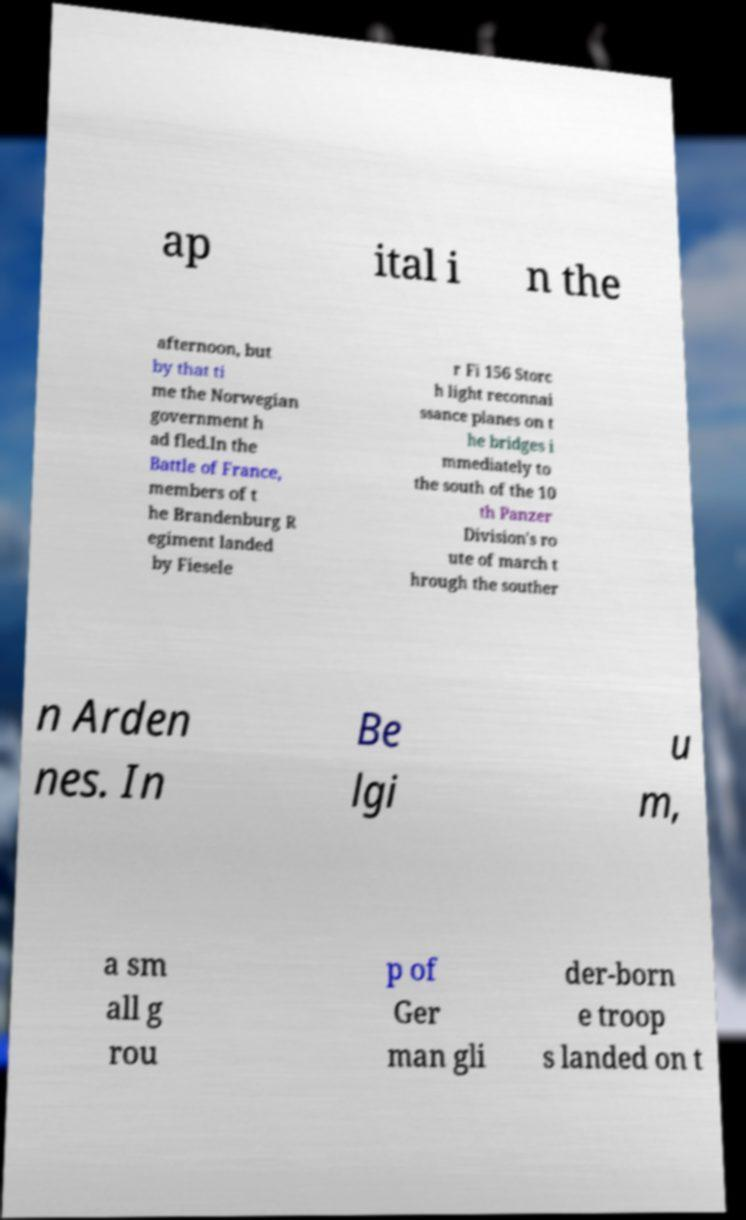For documentation purposes, I need the text within this image transcribed. Could you provide that? ap ital i n the afternoon, but by that ti me the Norwegian government h ad fled.In the Battle of France, members of t he Brandenburg R egiment landed by Fiesele r Fi 156 Storc h light reconnai ssance planes on t he bridges i mmediately to the south of the 10 th Panzer Division's ro ute of march t hrough the souther n Arden nes. In Be lgi u m, a sm all g rou p of Ger man gli der-born e troop s landed on t 